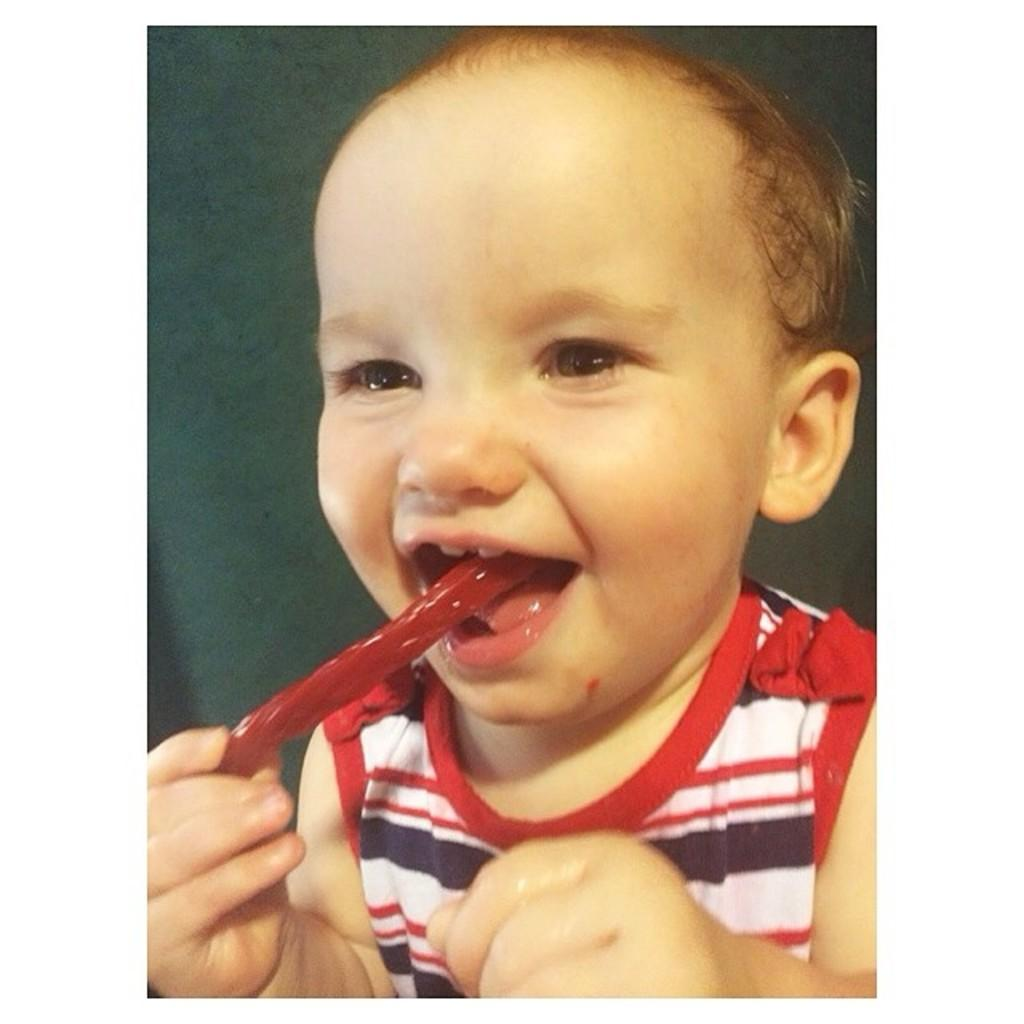What is the main subject of the image? The main subject of the image is a kid. What is the kid doing in the image? The kid is eating a red color food item. What type of air is being used to style the kid's hair in the image? There is no mention of hair or styling in the image, so it cannot be determined if any air is being used. 